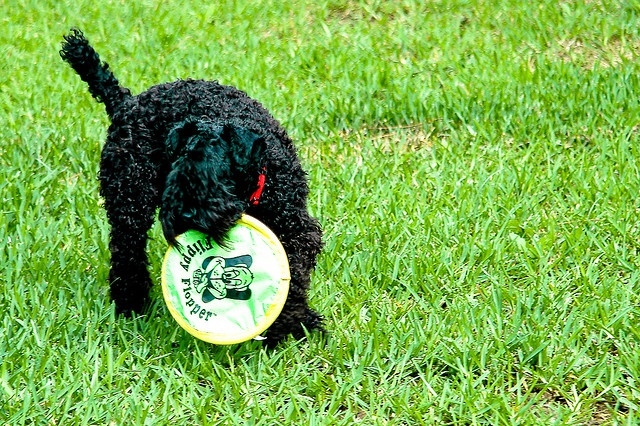Describe the objects in this image and their specific colors. I can see dog in lightgreen, black, ivory, teal, and gray tones and frisbee in lightgreen, ivory, khaki, and black tones in this image. 